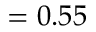<formula> <loc_0><loc_0><loc_500><loc_500>= 0 . 5 5</formula> 